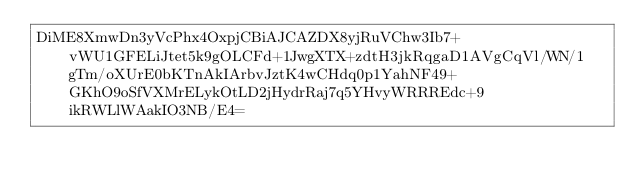Convert code to text. <code><loc_0><loc_0><loc_500><loc_500><_SML_>DiME8XmwDn3yVcPhx4OxpjCBiAJCAZDX8yjRuVChw3Ib7+vWU1GFELiJtet5k9gOLCFd+1JwgXTX+zdtH3jkRqgaD1AVgCqVl/WN/1gTm/oXUrE0bKTnAkIArbvJztK4wCHdq0p1YahNF49+GKhO9oSfVXMrELykOtLD2jHydrRaj7q5YHvyWRRREdc+9ikRWLlWAakIO3NB/E4=</code> 